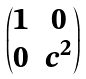Convert formula to latex. <formula><loc_0><loc_0><loc_500><loc_500>\begin{pmatrix} 1 & 0 \\ 0 & c ^ { 2 } \end{pmatrix}</formula> 